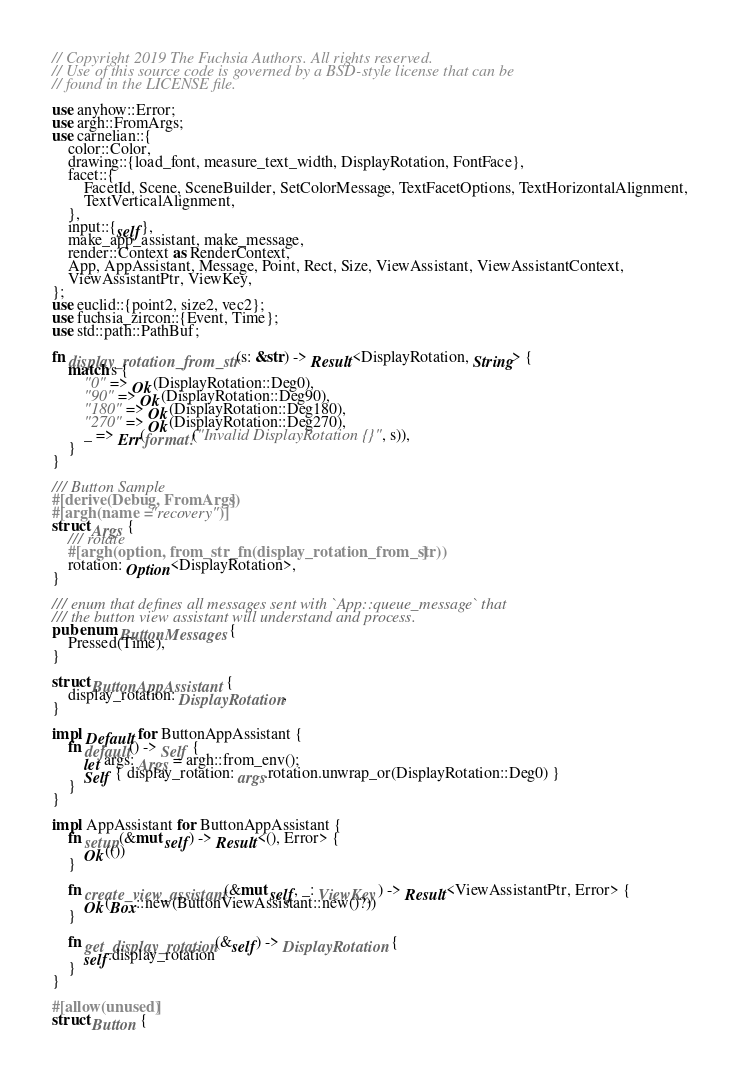<code> <loc_0><loc_0><loc_500><loc_500><_Rust_>// Copyright 2019 The Fuchsia Authors. All rights reserved.
// Use of this source code is governed by a BSD-style license that can be
// found in the LICENSE file.

use anyhow::Error;
use argh::FromArgs;
use carnelian::{
    color::Color,
    drawing::{load_font, measure_text_width, DisplayRotation, FontFace},
    facet::{
        FacetId, Scene, SceneBuilder, SetColorMessage, TextFacetOptions, TextHorizontalAlignment,
        TextVerticalAlignment,
    },
    input::{self},
    make_app_assistant, make_message,
    render::Context as RenderContext,
    App, AppAssistant, Message, Point, Rect, Size, ViewAssistant, ViewAssistantContext,
    ViewAssistantPtr, ViewKey,
};
use euclid::{point2, size2, vec2};
use fuchsia_zircon::{Event, Time};
use std::path::PathBuf;

fn display_rotation_from_str(s: &str) -> Result<DisplayRotation, String> {
    match s {
        "0" => Ok(DisplayRotation::Deg0),
        "90" => Ok(DisplayRotation::Deg90),
        "180" => Ok(DisplayRotation::Deg180),
        "270" => Ok(DisplayRotation::Deg270),
        _ => Err(format!("Invalid DisplayRotation {}", s)),
    }
}

/// Button Sample
#[derive(Debug, FromArgs)]
#[argh(name = "recovery")]
struct Args {
    /// rotate
    #[argh(option, from_str_fn(display_rotation_from_str))]
    rotation: Option<DisplayRotation>,
}

/// enum that defines all messages sent with `App::queue_message` that
/// the button view assistant will understand and process.
pub enum ButtonMessages {
    Pressed(Time),
}

struct ButtonAppAssistant {
    display_rotation: DisplayRotation,
}

impl Default for ButtonAppAssistant {
    fn default() -> Self {
        let args: Args = argh::from_env();
        Self { display_rotation: args.rotation.unwrap_or(DisplayRotation::Deg0) }
    }
}

impl AppAssistant for ButtonAppAssistant {
    fn setup(&mut self) -> Result<(), Error> {
        Ok(())
    }

    fn create_view_assistant(&mut self, _: ViewKey) -> Result<ViewAssistantPtr, Error> {
        Ok(Box::new(ButtonViewAssistant::new()?))
    }

    fn get_display_rotation(&self) -> DisplayRotation {
        self.display_rotation
    }
}

#[allow(unused)]
struct Button {</code> 